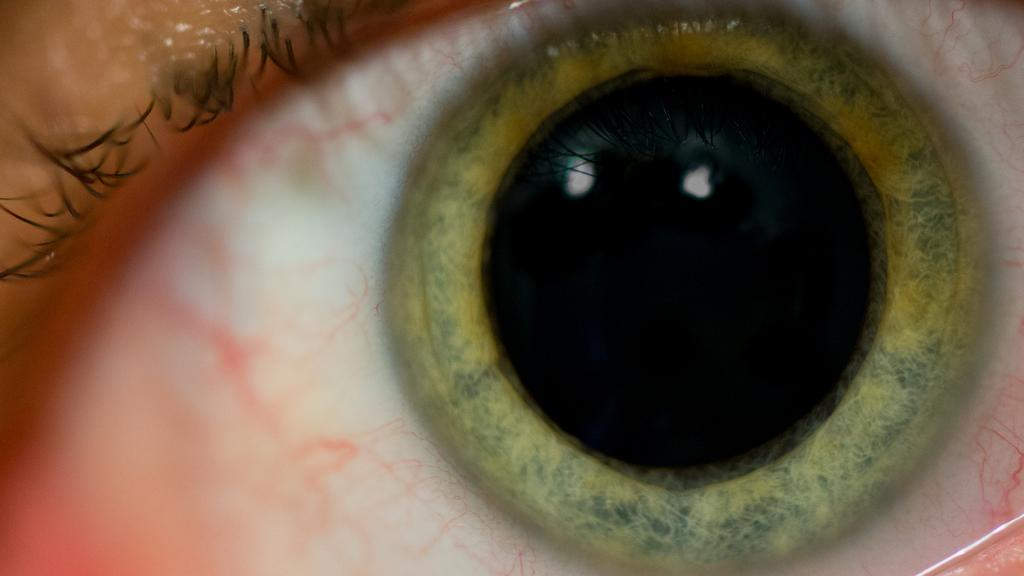What is the main subject in the foreground of the image? There is an eye in the foreground of the image. How many cows can be seen grazing in the background of the image? There are no cows present in the image; it only features an eye in the foreground. 